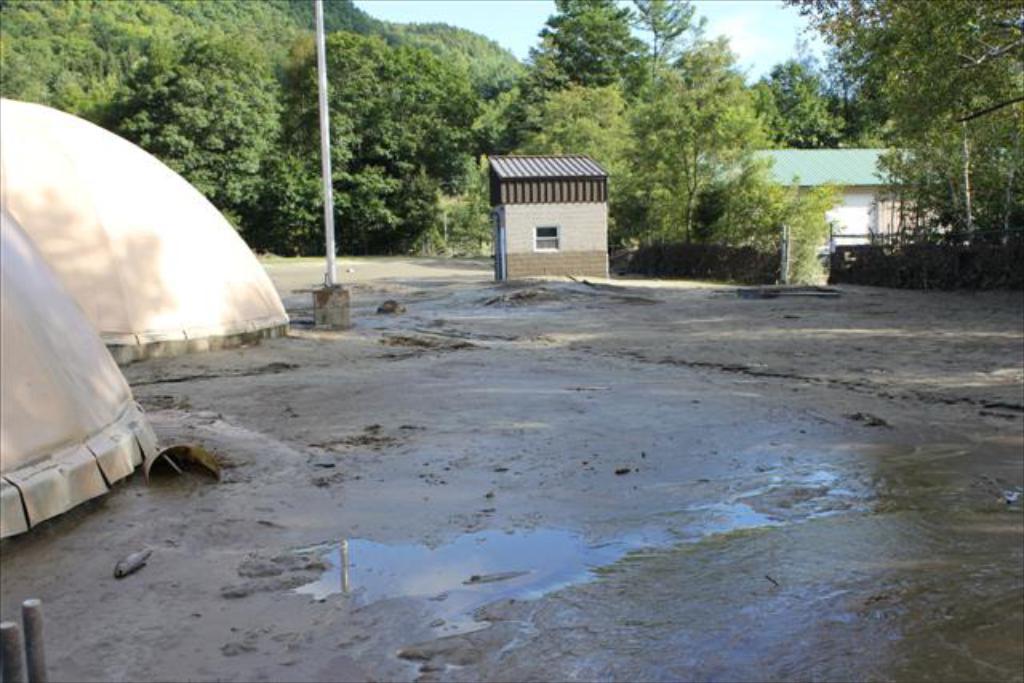Please provide a concise description of this image. In this image we can see mud, tents, poles, sheds, and trees. In the background there is sky. 